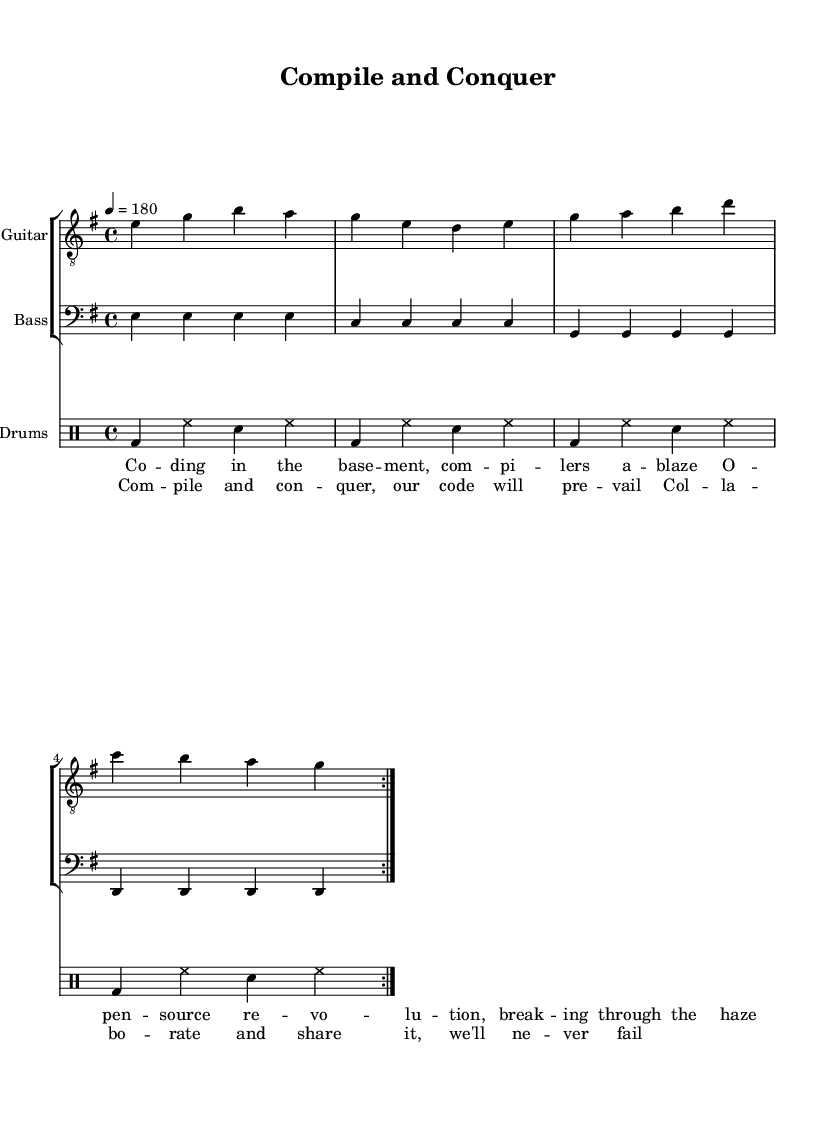What is the key signature of this music? The key signature is E minor, which has one sharp (F#). This can be inferred from the global settings in the code that specifies the key.
Answer: E minor What is the time signature of this music? The time signature is 4/4, as stated in the global settings. This means there are four beats in each measure, and the quarter note gets one beat.
Answer: 4/4 What is the tempo of this song? The tempo is set at 180 beats per minute, as indicated by the tempo marking in the global section of the code.
Answer: 180 How many measures are there in the guitar part? The guitar part consists of 8 measures, as it uses a repeat sign and each volta contains 4 measures repeated once. 4 measures in the volta x 2 = 8 total measures.
Answer: 8 What instruments are featured in this score? The featured instruments are Guitar, Bass, and Drums. This is evident from the staff groupings and their respective labels in the score.
Answer: Guitar, Bass, Drums What themes are represented in the lyrics? The lyrics celebrate collaboration and open-source coding, referring to 'open-source revolution' and 'collaborate and share'. These phrases indicate a focus on teamwork and sharing knowledge in coding.
Answer: Collaboration, Open-source 